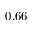Convert formula to latex. <formula><loc_0><loc_0><loc_500><loc_500>0 . 6 6</formula> 